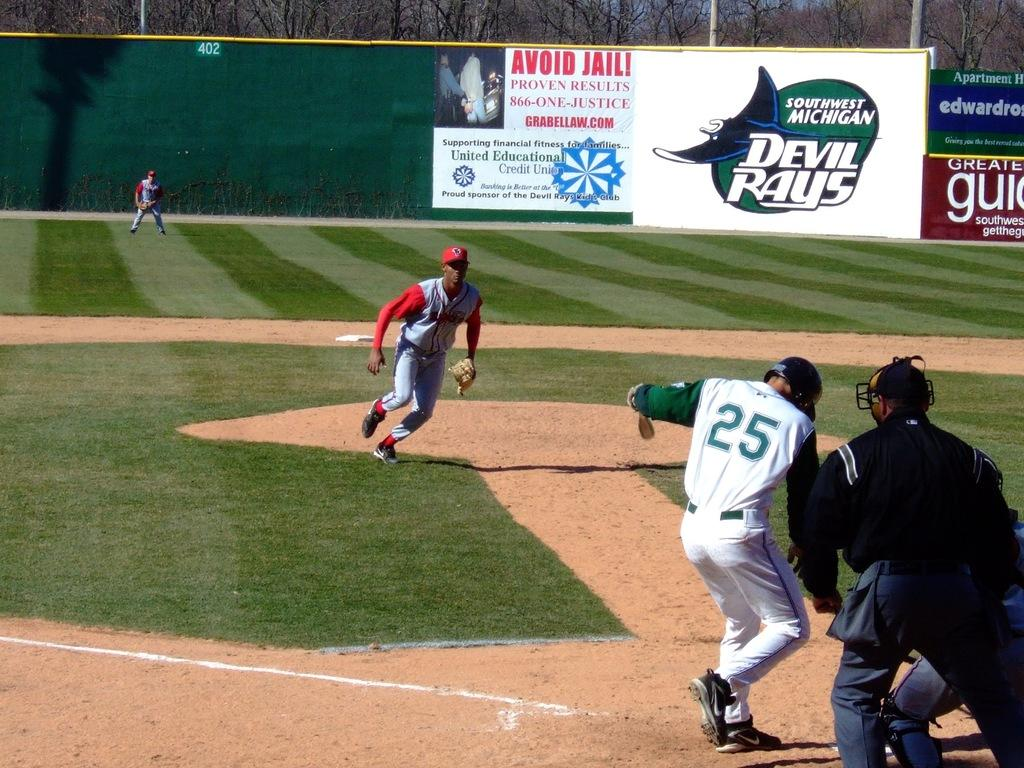<image>
Relay a brief, clear account of the picture shown. A Devil Rays player tries to get out of the way of a pitch. 